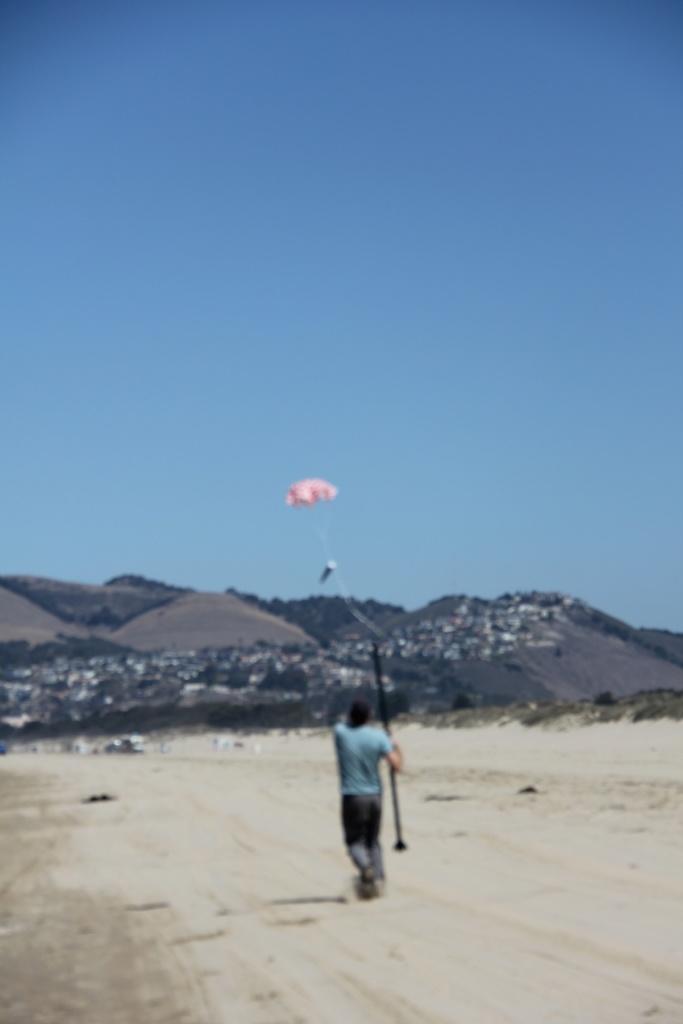Please provide a concise description of this image. In this image there is a person running by holding some object. At the bottom of the image there is sand. In the background of the image there are buildings, trees, mountains and sky. 